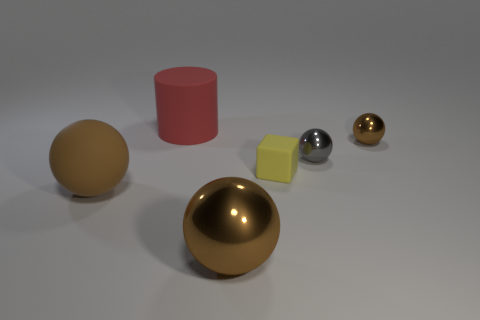Is there any other thing that is made of the same material as the big cylinder?
Provide a succinct answer. Yes. There is a large matte thing that is the same color as the large shiny sphere; what is its shape?
Give a very brief answer. Sphere. Is the shape of the large metal thing the same as the tiny brown thing?
Your answer should be compact. Yes. There is a sphere to the left of the rubber cylinder; what is its size?
Give a very brief answer. Large. There is a brown rubber object; is its size the same as the matte cylinder behind the big brown metallic object?
Make the answer very short. Yes. Is the number of tiny brown metallic balls that are on the right side of the small brown thing less than the number of matte blocks?
Your answer should be very brief. Yes. There is another small thing that is the same shape as the tiny brown metal thing; what material is it?
Keep it short and to the point. Metal. There is a thing that is both behind the gray metal object and to the right of the rubber block; what shape is it?
Ensure brevity in your answer.  Sphere. What is the shape of the big red object that is made of the same material as the yellow thing?
Your answer should be compact. Cylinder. There is a big ball to the right of the big rubber cylinder; what material is it?
Your answer should be compact. Metal. 